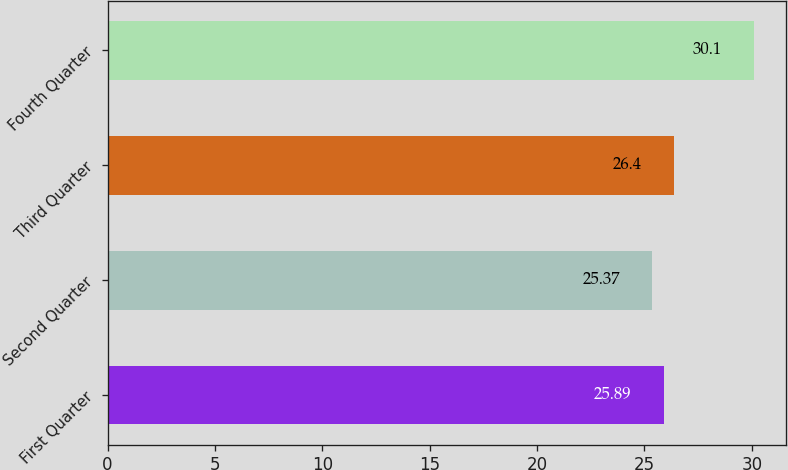Convert chart. <chart><loc_0><loc_0><loc_500><loc_500><bar_chart><fcel>First Quarter<fcel>Second Quarter<fcel>Third Quarter<fcel>Fourth Quarter<nl><fcel>25.89<fcel>25.37<fcel>26.4<fcel>30.1<nl></chart> 